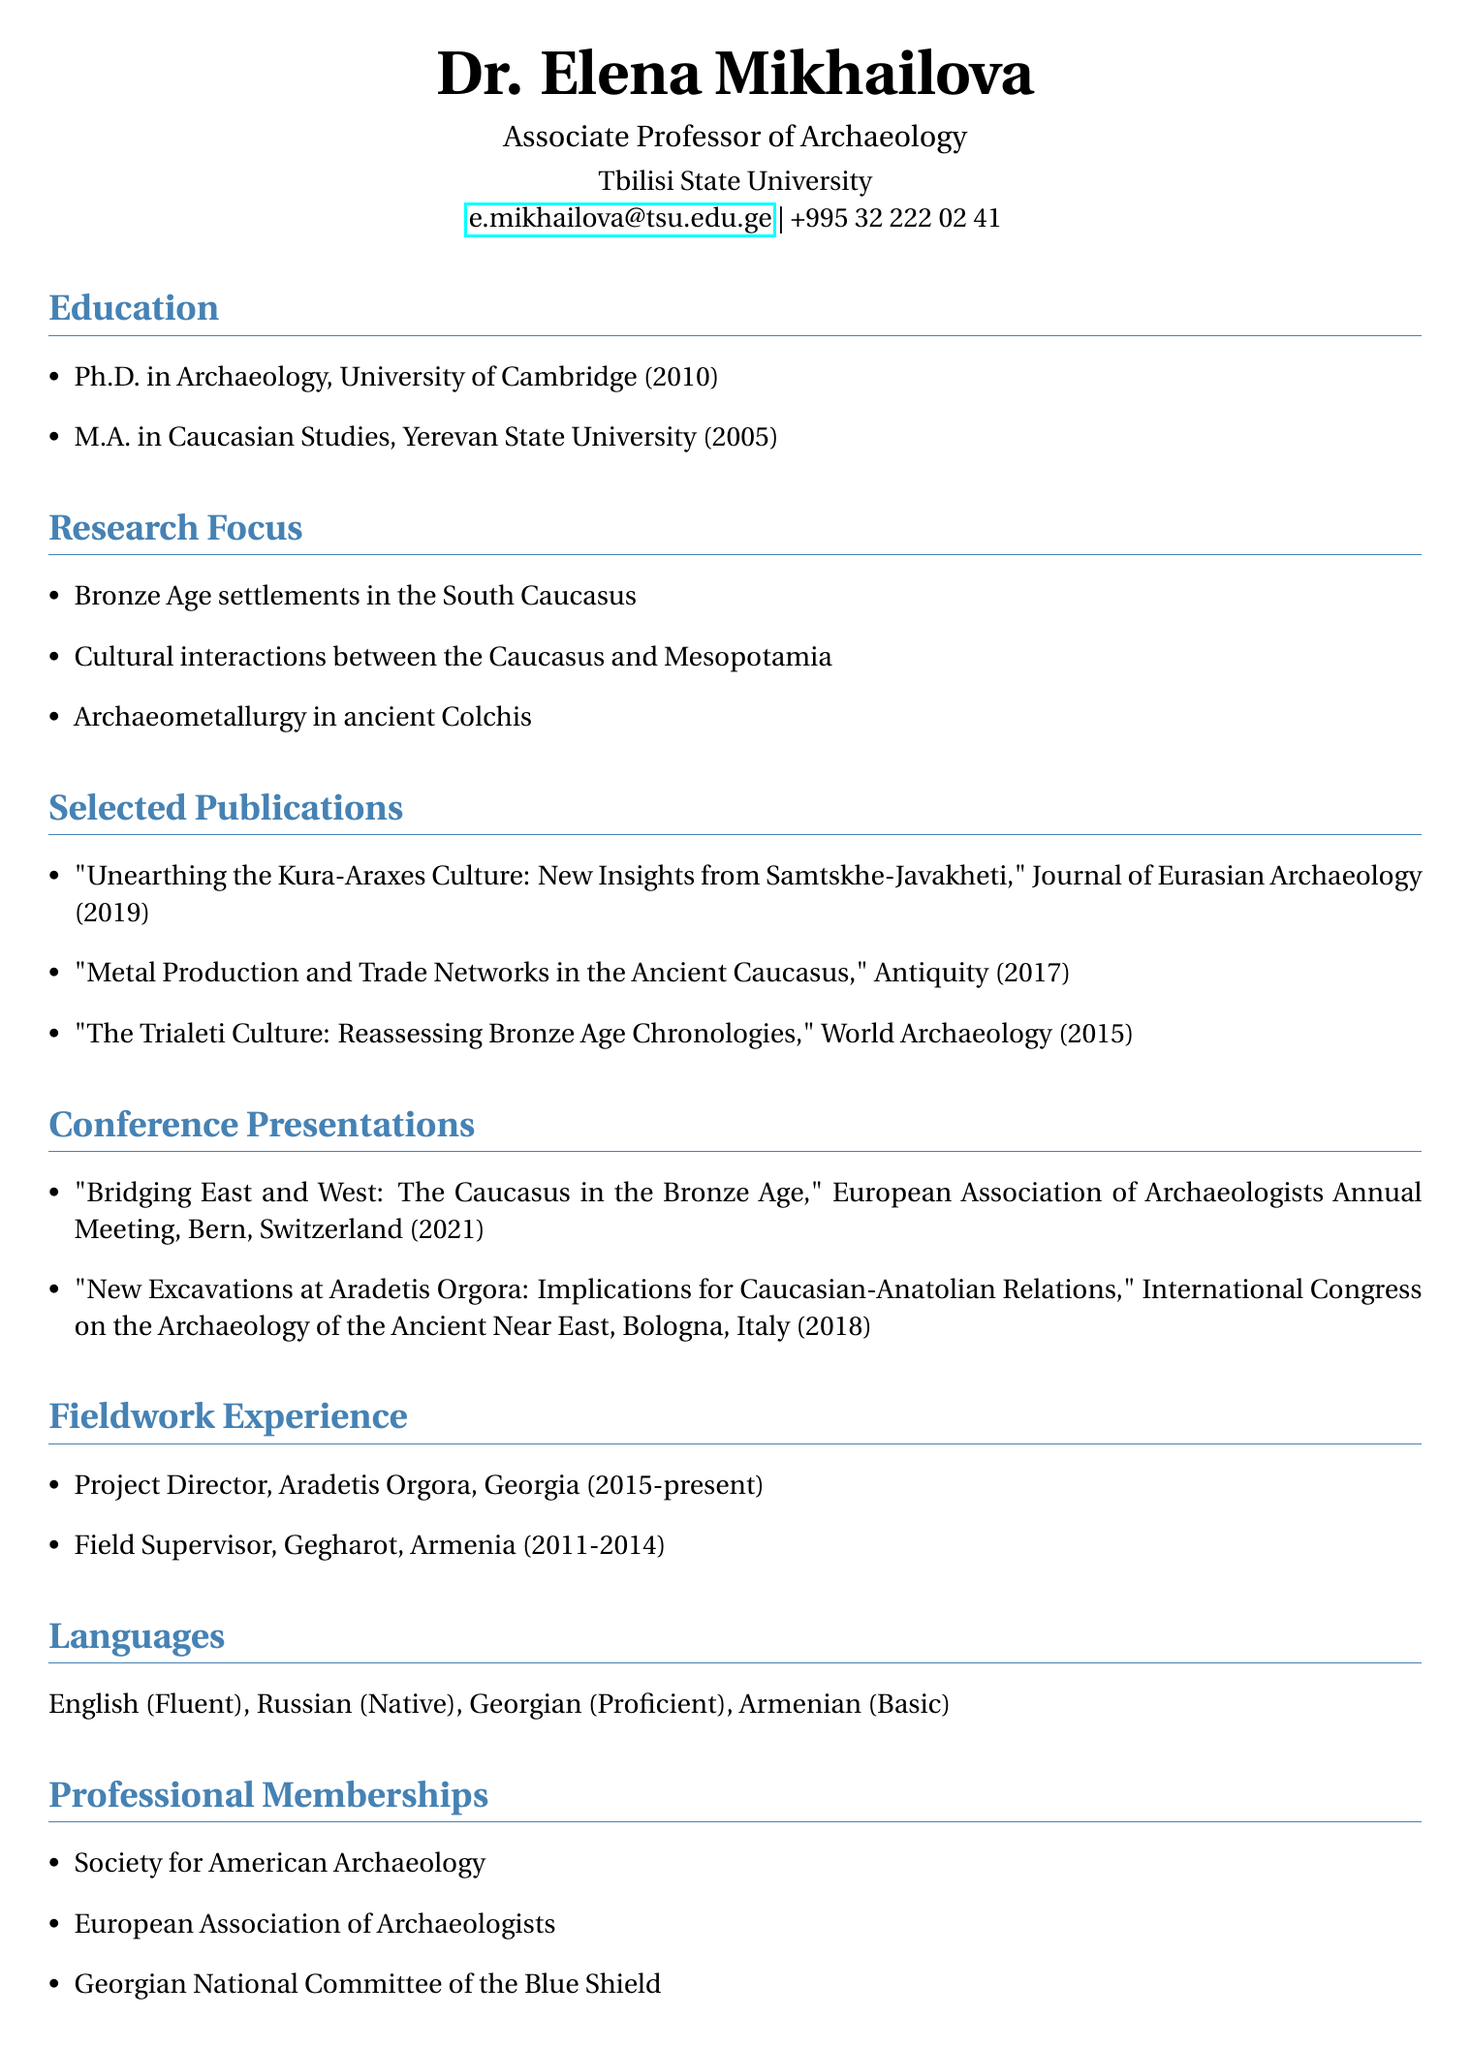what is the name of the associate professor? The name is listed at the top of the document as Dr. Elena Mikhailova.
Answer: Dr. Elena Mikhailova which university awarded her Ph.D.? The document states that she received her Ph.D. in Archaeology from the University of Cambridge.
Answer: University of Cambridge what is Dr. Mikhailova's research focus related to ancient cultures? One area of research focus mentioned in the document is "Cultural interactions between the Caucasus and Mesopotamia."
Answer: Cultural interactions between the Caucasus and Mesopotamia how many selected publications does Dr. Mikhailova have? The document lists three selected publications under her research contributions.
Answer: Three in which year was the presentation on Caucasian-Anatolian relations given? The conference presentation on Caucasian-Anatolian relations is noted as taking place in 2018.
Answer: 2018 what is Dr. Mikhailova's role at Aradetis Orgora? According to the document, she serves as the Project Director at Aradetis Orgora.
Answer: Project Director which language is she proficient in, other than her native language? The document indicates that she is proficient in Georgian.
Answer: Georgian how many years did she work as a Field Supervisor in Armenia? She worked as a Field Supervisor from 2011 to 2014, totaling four years.
Answer: Four years 